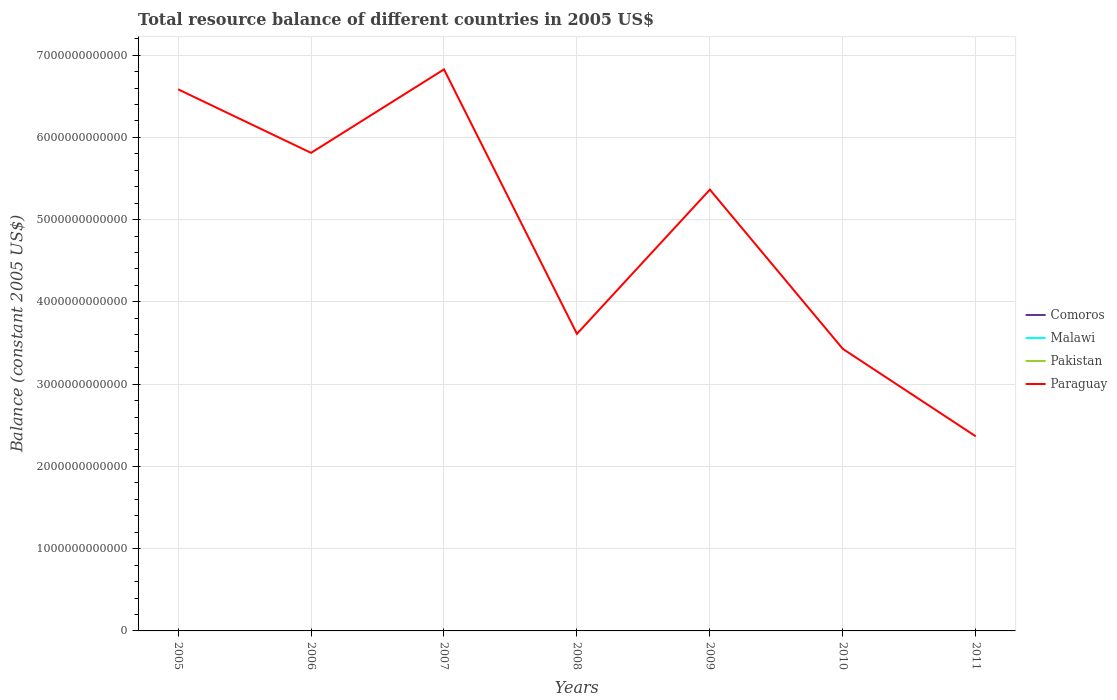How many different coloured lines are there?
Ensure brevity in your answer.  1. Is the number of lines equal to the number of legend labels?
Offer a terse response. No. Across all years, what is the maximum total resource balance in Paraguay?
Keep it short and to the point. 2.37e+12. What is the total total resource balance in Paraguay in the graph?
Make the answer very short. -1.75e+12. What is the difference between the highest and the second highest total resource balance in Paraguay?
Your answer should be very brief. 4.46e+12. How many years are there in the graph?
Give a very brief answer. 7. What is the difference between two consecutive major ticks on the Y-axis?
Offer a terse response. 1.00e+12. Does the graph contain any zero values?
Keep it short and to the point. Yes. How many legend labels are there?
Make the answer very short. 4. How are the legend labels stacked?
Your answer should be compact. Vertical. What is the title of the graph?
Offer a terse response. Total resource balance of different countries in 2005 US$. Does "Madagascar" appear as one of the legend labels in the graph?
Provide a short and direct response. No. What is the label or title of the X-axis?
Give a very brief answer. Years. What is the label or title of the Y-axis?
Give a very brief answer. Balance (constant 2005 US$). What is the Balance (constant 2005 US$) of Comoros in 2005?
Ensure brevity in your answer.  0. What is the Balance (constant 2005 US$) of Malawi in 2005?
Provide a short and direct response. 0. What is the Balance (constant 2005 US$) in Paraguay in 2005?
Offer a terse response. 6.58e+12. What is the Balance (constant 2005 US$) of Comoros in 2006?
Offer a terse response. 0. What is the Balance (constant 2005 US$) of Malawi in 2006?
Your response must be concise. 0. What is the Balance (constant 2005 US$) of Pakistan in 2006?
Give a very brief answer. 0. What is the Balance (constant 2005 US$) in Paraguay in 2006?
Provide a short and direct response. 5.81e+12. What is the Balance (constant 2005 US$) of Comoros in 2007?
Provide a succinct answer. 0. What is the Balance (constant 2005 US$) in Malawi in 2007?
Your response must be concise. 0. What is the Balance (constant 2005 US$) of Pakistan in 2007?
Your response must be concise. 0. What is the Balance (constant 2005 US$) of Paraguay in 2007?
Offer a very short reply. 6.83e+12. What is the Balance (constant 2005 US$) in Malawi in 2008?
Offer a very short reply. 0. What is the Balance (constant 2005 US$) of Pakistan in 2008?
Ensure brevity in your answer.  0. What is the Balance (constant 2005 US$) in Paraguay in 2008?
Your answer should be very brief. 3.61e+12. What is the Balance (constant 2005 US$) of Malawi in 2009?
Your response must be concise. 0. What is the Balance (constant 2005 US$) of Pakistan in 2009?
Give a very brief answer. 0. What is the Balance (constant 2005 US$) in Paraguay in 2009?
Provide a succinct answer. 5.36e+12. What is the Balance (constant 2005 US$) of Malawi in 2010?
Keep it short and to the point. 0. What is the Balance (constant 2005 US$) of Paraguay in 2010?
Give a very brief answer. 3.43e+12. What is the Balance (constant 2005 US$) of Pakistan in 2011?
Your response must be concise. 0. What is the Balance (constant 2005 US$) of Paraguay in 2011?
Your answer should be very brief. 2.37e+12. Across all years, what is the maximum Balance (constant 2005 US$) in Paraguay?
Offer a terse response. 6.83e+12. Across all years, what is the minimum Balance (constant 2005 US$) of Paraguay?
Your answer should be very brief. 2.37e+12. What is the total Balance (constant 2005 US$) of Comoros in the graph?
Give a very brief answer. 0. What is the total Balance (constant 2005 US$) of Malawi in the graph?
Make the answer very short. 0. What is the total Balance (constant 2005 US$) of Paraguay in the graph?
Provide a succinct answer. 3.40e+13. What is the difference between the Balance (constant 2005 US$) in Paraguay in 2005 and that in 2006?
Your answer should be compact. 7.73e+11. What is the difference between the Balance (constant 2005 US$) in Paraguay in 2005 and that in 2007?
Keep it short and to the point. -2.42e+11. What is the difference between the Balance (constant 2005 US$) of Paraguay in 2005 and that in 2008?
Offer a terse response. 2.97e+12. What is the difference between the Balance (constant 2005 US$) of Paraguay in 2005 and that in 2009?
Provide a succinct answer. 1.22e+12. What is the difference between the Balance (constant 2005 US$) of Paraguay in 2005 and that in 2010?
Your answer should be very brief. 3.16e+12. What is the difference between the Balance (constant 2005 US$) in Paraguay in 2005 and that in 2011?
Provide a short and direct response. 4.22e+12. What is the difference between the Balance (constant 2005 US$) of Paraguay in 2006 and that in 2007?
Keep it short and to the point. -1.01e+12. What is the difference between the Balance (constant 2005 US$) of Paraguay in 2006 and that in 2008?
Ensure brevity in your answer.  2.20e+12. What is the difference between the Balance (constant 2005 US$) of Paraguay in 2006 and that in 2009?
Your answer should be compact. 4.47e+11. What is the difference between the Balance (constant 2005 US$) in Paraguay in 2006 and that in 2010?
Your response must be concise. 2.38e+12. What is the difference between the Balance (constant 2005 US$) in Paraguay in 2006 and that in 2011?
Provide a short and direct response. 3.45e+12. What is the difference between the Balance (constant 2005 US$) in Paraguay in 2007 and that in 2008?
Ensure brevity in your answer.  3.22e+12. What is the difference between the Balance (constant 2005 US$) of Paraguay in 2007 and that in 2009?
Offer a terse response. 1.46e+12. What is the difference between the Balance (constant 2005 US$) in Paraguay in 2007 and that in 2010?
Provide a short and direct response. 3.40e+12. What is the difference between the Balance (constant 2005 US$) of Paraguay in 2007 and that in 2011?
Your answer should be very brief. 4.46e+12. What is the difference between the Balance (constant 2005 US$) in Paraguay in 2008 and that in 2009?
Your answer should be compact. -1.75e+12. What is the difference between the Balance (constant 2005 US$) in Paraguay in 2008 and that in 2010?
Ensure brevity in your answer.  1.83e+11. What is the difference between the Balance (constant 2005 US$) in Paraguay in 2008 and that in 2011?
Your answer should be compact. 1.25e+12. What is the difference between the Balance (constant 2005 US$) of Paraguay in 2009 and that in 2010?
Ensure brevity in your answer.  1.94e+12. What is the difference between the Balance (constant 2005 US$) of Paraguay in 2009 and that in 2011?
Provide a short and direct response. 3.00e+12. What is the difference between the Balance (constant 2005 US$) of Paraguay in 2010 and that in 2011?
Your response must be concise. 1.06e+12. What is the average Balance (constant 2005 US$) in Comoros per year?
Keep it short and to the point. 0. What is the average Balance (constant 2005 US$) of Pakistan per year?
Ensure brevity in your answer.  0. What is the average Balance (constant 2005 US$) of Paraguay per year?
Provide a succinct answer. 4.86e+12. What is the ratio of the Balance (constant 2005 US$) in Paraguay in 2005 to that in 2006?
Your answer should be compact. 1.13. What is the ratio of the Balance (constant 2005 US$) of Paraguay in 2005 to that in 2007?
Your answer should be compact. 0.96. What is the ratio of the Balance (constant 2005 US$) in Paraguay in 2005 to that in 2008?
Ensure brevity in your answer.  1.82. What is the ratio of the Balance (constant 2005 US$) of Paraguay in 2005 to that in 2009?
Provide a succinct answer. 1.23. What is the ratio of the Balance (constant 2005 US$) in Paraguay in 2005 to that in 2010?
Keep it short and to the point. 1.92. What is the ratio of the Balance (constant 2005 US$) in Paraguay in 2005 to that in 2011?
Give a very brief answer. 2.78. What is the ratio of the Balance (constant 2005 US$) of Paraguay in 2006 to that in 2007?
Provide a succinct answer. 0.85. What is the ratio of the Balance (constant 2005 US$) of Paraguay in 2006 to that in 2008?
Make the answer very short. 1.61. What is the ratio of the Balance (constant 2005 US$) in Paraguay in 2006 to that in 2009?
Your response must be concise. 1.08. What is the ratio of the Balance (constant 2005 US$) in Paraguay in 2006 to that in 2010?
Provide a short and direct response. 1.7. What is the ratio of the Balance (constant 2005 US$) of Paraguay in 2006 to that in 2011?
Provide a short and direct response. 2.46. What is the ratio of the Balance (constant 2005 US$) in Paraguay in 2007 to that in 2008?
Provide a short and direct response. 1.89. What is the ratio of the Balance (constant 2005 US$) of Paraguay in 2007 to that in 2009?
Provide a succinct answer. 1.27. What is the ratio of the Balance (constant 2005 US$) in Paraguay in 2007 to that in 2010?
Keep it short and to the point. 1.99. What is the ratio of the Balance (constant 2005 US$) of Paraguay in 2007 to that in 2011?
Give a very brief answer. 2.89. What is the ratio of the Balance (constant 2005 US$) in Paraguay in 2008 to that in 2009?
Your answer should be very brief. 0.67. What is the ratio of the Balance (constant 2005 US$) in Paraguay in 2008 to that in 2010?
Keep it short and to the point. 1.05. What is the ratio of the Balance (constant 2005 US$) of Paraguay in 2008 to that in 2011?
Provide a short and direct response. 1.53. What is the ratio of the Balance (constant 2005 US$) in Paraguay in 2009 to that in 2010?
Keep it short and to the point. 1.56. What is the ratio of the Balance (constant 2005 US$) of Paraguay in 2009 to that in 2011?
Your response must be concise. 2.27. What is the ratio of the Balance (constant 2005 US$) in Paraguay in 2010 to that in 2011?
Keep it short and to the point. 1.45. What is the difference between the highest and the second highest Balance (constant 2005 US$) of Paraguay?
Give a very brief answer. 2.42e+11. What is the difference between the highest and the lowest Balance (constant 2005 US$) in Paraguay?
Make the answer very short. 4.46e+12. 